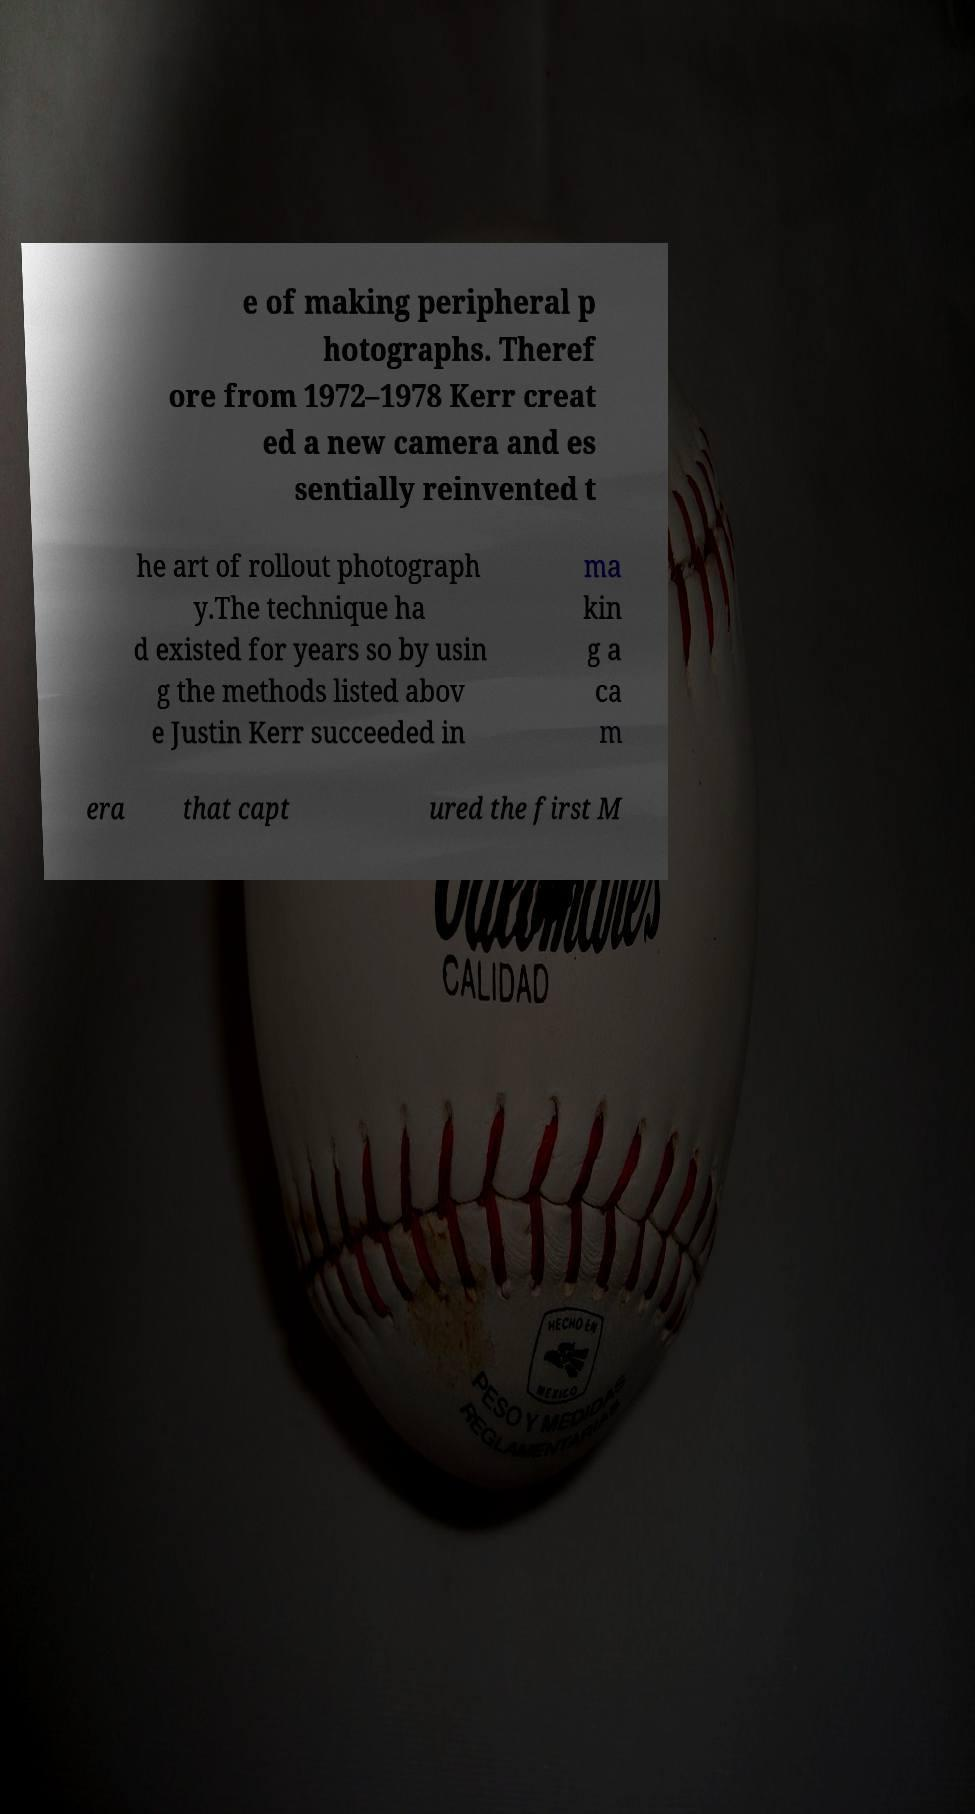Could you extract and type out the text from this image? e of making peripheral p hotographs. Theref ore from 1972–1978 Kerr creat ed a new camera and es sentially reinvented t he art of rollout photograph y.The technique ha d existed for years so by usin g the methods listed abov e Justin Kerr succeeded in ma kin g a ca m era that capt ured the first M 